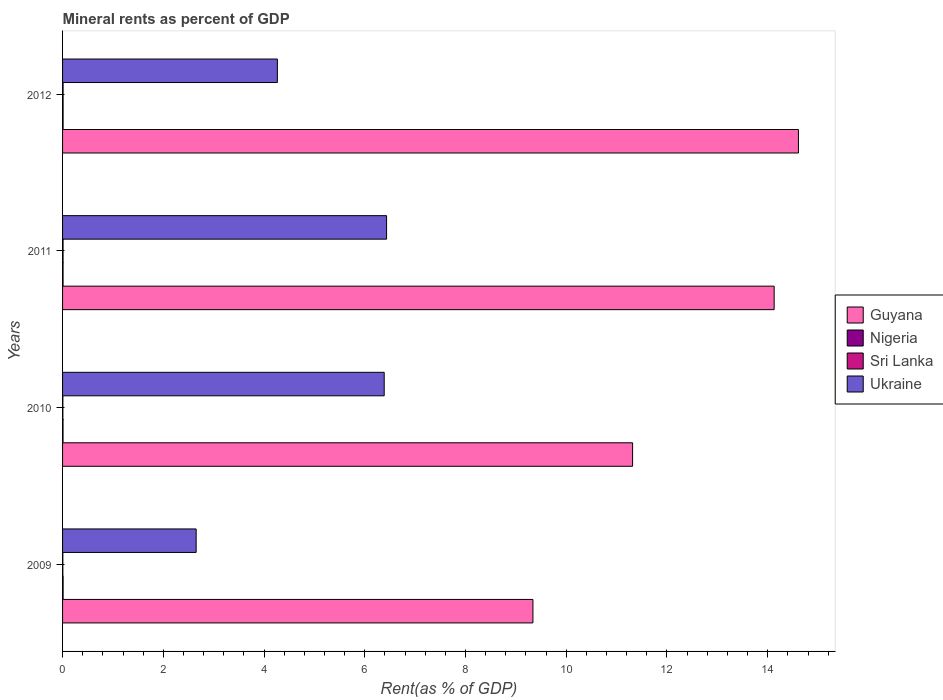How many groups of bars are there?
Give a very brief answer. 4. Are the number of bars per tick equal to the number of legend labels?
Your answer should be very brief. Yes. Are the number of bars on each tick of the Y-axis equal?
Your answer should be very brief. Yes. How many bars are there on the 3rd tick from the bottom?
Your answer should be very brief. 4. In how many cases, is the number of bars for a given year not equal to the number of legend labels?
Ensure brevity in your answer.  0. What is the mineral rent in Guyana in 2011?
Provide a short and direct response. 14.13. Across all years, what is the maximum mineral rent in Guyana?
Make the answer very short. 14.61. Across all years, what is the minimum mineral rent in Nigeria?
Offer a terse response. 0.01. In which year was the mineral rent in Guyana minimum?
Provide a succinct answer. 2009. What is the total mineral rent in Nigeria in the graph?
Offer a terse response. 0.04. What is the difference between the mineral rent in Nigeria in 2010 and that in 2012?
Offer a very short reply. -0. What is the difference between the mineral rent in Nigeria in 2011 and the mineral rent in Guyana in 2012?
Keep it short and to the point. -14.6. What is the average mineral rent in Guyana per year?
Provide a succinct answer. 12.35. In the year 2010, what is the difference between the mineral rent in Ukraine and mineral rent in Sri Lanka?
Your response must be concise. 6.38. What is the ratio of the mineral rent in Ukraine in 2011 to that in 2012?
Your answer should be compact. 1.51. Is the mineral rent in Guyana in 2009 less than that in 2010?
Offer a terse response. Yes. What is the difference between the highest and the second highest mineral rent in Sri Lanka?
Ensure brevity in your answer.  0. What is the difference between the highest and the lowest mineral rent in Nigeria?
Offer a terse response. 0. In how many years, is the mineral rent in Guyana greater than the average mineral rent in Guyana taken over all years?
Offer a terse response. 2. Is the sum of the mineral rent in Ukraine in 2009 and 2010 greater than the maximum mineral rent in Nigeria across all years?
Your response must be concise. Yes. Is it the case that in every year, the sum of the mineral rent in Sri Lanka and mineral rent in Guyana is greater than the sum of mineral rent in Nigeria and mineral rent in Ukraine?
Keep it short and to the point. Yes. What does the 4th bar from the top in 2011 represents?
Provide a short and direct response. Guyana. What does the 1st bar from the bottom in 2009 represents?
Give a very brief answer. Guyana. How many bars are there?
Keep it short and to the point. 16. How many years are there in the graph?
Keep it short and to the point. 4. What is the difference between two consecutive major ticks on the X-axis?
Your response must be concise. 2. Are the values on the major ticks of X-axis written in scientific E-notation?
Your answer should be compact. No. How many legend labels are there?
Keep it short and to the point. 4. What is the title of the graph?
Ensure brevity in your answer.  Mineral rents as percent of GDP. What is the label or title of the X-axis?
Offer a very short reply. Rent(as % of GDP). What is the label or title of the Y-axis?
Make the answer very short. Years. What is the Rent(as % of GDP) in Guyana in 2009?
Offer a very short reply. 9.34. What is the Rent(as % of GDP) in Nigeria in 2009?
Provide a succinct answer. 0.01. What is the Rent(as % of GDP) of Sri Lanka in 2009?
Your response must be concise. 0.01. What is the Rent(as % of GDP) in Ukraine in 2009?
Offer a very short reply. 2.65. What is the Rent(as % of GDP) of Guyana in 2010?
Offer a very short reply. 11.32. What is the Rent(as % of GDP) in Nigeria in 2010?
Provide a succinct answer. 0.01. What is the Rent(as % of GDP) of Sri Lanka in 2010?
Your answer should be very brief. 0.01. What is the Rent(as % of GDP) of Ukraine in 2010?
Offer a terse response. 6.39. What is the Rent(as % of GDP) in Guyana in 2011?
Offer a very short reply. 14.13. What is the Rent(as % of GDP) in Nigeria in 2011?
Your answer should be compact. 0.01. What is the Rent(as % of GDP) of Sri Lanka in 2011?
Give a very brief answer. 0.01. What is the Rent(as % of GDP) in Ukraine in 2011?
Your answer should be compact. 6.43. What is the Rent(as % of GDP) in Guyana in 2012?
Your response must be concise. 14.61. What is the Rent(as % of GDP) of Nigeria in 2012?
Ensure brevity in your answer.  0.01. What is the Rent(as % of GDP) in Sri Lanka in 2012?
Provide a succinct answer. 0.01. What is the Rent(as % of GDP) in Ukraine in 2012?
Your response must be concise. 4.26. Across all years, what is the maximum Rent(as % of GDP) in Guyana?
Make the answer very short. 14.61. Across all years, what is the maximum Rent(as % of GDP) in Nigeria?
Provide a short and direct response. 0.01. Across all years, what is the maximum Rent(as % of GDP) of Sri Lanka?
Make the answer very short. 0.01. Across all years, what is the maximum Rent(as % of GDP) in Ukraine?
Your response must be concise. 6.43. Across all years, what is the minimum Rent(as % of GDP) of Guyana?
Offer a very short reply. 9.34. Across all years, what is the minimum Rent(as % of GDP) of Nigeria?
Offer a very short reply. 0.01. Across all years, what is the minimum Rent(as % of GDP) in Sri Lanka?
Give a very brief answer. 0.01. Across all years, what is the minimum Rent(as % of GDP) in Ukraine?
Offer a very short reply. 2.65. What is the total Rent(as % of GDP) in Guyana in the graph?
Offer a terse response. 49.39. What is the total Rent(as % of GDP) of Nigeria in the graph?
Ensure brevity in your answer.  0.04. What is the total Rent(as % of GDP) of Sri Lanka in the graph?
Ensure brevity in your answer.  0.03. What is the total Rent(as % of GDP) of Ukraine in the graph?
Keep it short and to the point. 19.74. What is the difference between the Rent(as % of GDP) in Guyana in 2009 and that in 2010?
Keep it short and to the point. -1.98. What is the difference between the Rent(as % of GDP) in Nigeria in 2009 and that in 2010?
Your response must be concise. 0. What is the difference between the Rent(as % of GDP) in Sri Lanka in 2009 and that in 2010?
Ensure brevity in your answer.  -0. What is the difference between the Rent(as % of GDP) in Ukraine in 2009 and that in 2010?
Provide a short and direct response. -3.73. What is the difference between the Rent(as % of GDP) of Guyana in 2009 and that in 2011?
Your answer should be compact. -4.79. What is the difference between the Rent(as % of GDP) in Sri Lanka in 2009 and that in 2011?
Keep it short and to the point. -0. What is the difference between the Rent(as % of GDP) in Ukraine in 2009 and that in 2011?
Provide a succinct answer. -3.78. What is the difference between the Rent(as % of GDP) of Guyana in 2009 and that in 2012?
Give a very brief answer. -5.27. What is the difference between the Rent(as % of GDP) of Nigeria in 2009 and that in 2012?
Ensure brevity in your answer.  0. What is the difference between the Rent(as % of GDP) of Sri Lanka in 2009 and that in 2012?
Keep it short and to the point. -0. What is the difference between the Rent(as % of GDP) of Ukraine in 2009 and that in 2012?
Provide a short and direct response. -1.61. What is the difference between the Rent(as % of GDP) in Guyana in 2010 and that in 2011?
Ensure brevity in your answer.  -2.81. What is the difference between the Rent(as % of GDP) of Nigeria in 2010 and that in 2011?
Give a very brief answer. -0. What is the difference between the Rent(as % of GDP) of Sri Lanka in 2010 and that in 2011?
Your response must be concise. -0. What is the difference between the Rent(as % of GDP) of Ukraine in 2010 and that in 2011?
Your answer should be compact. -0.05. What is the difference between the Rent(as % of GDP) in Guyana in 2010 and that in 2012?
Make the answer very short. -3.29. What is the difference between the Rent(as % of GDP) in Nigeria in 2010 and that in 2012?
Your answer should be compact. -0. What is the difference between the Rent(as % of GDP) in Sri Lanka in 2010 and that in 2012?
Ensure brevity in your answer.  -0. What is the difference between the Rent(as % of GDP) of Ukraine in 2010 and that in 2012?
Offer a very short reply. 2.12. What is the difference between the Rent(as % of GDP) of Guyana in 2011 and that in 2012?
Your answer should be very brief. -0.48. What is the difference between the Rent(as % of GDP) in Nigeria in 2011 and that in 2012?
Keep it short and to the point. -0. What is the difference between the Rent(as % of GDP) of Sri Lanka in 2011 and that in 2012?
Offer a terse response. -0. What is the difference between the Rent(as % of GDP) of Ukraine in 2011 and that in 2012?
Keep it short and to the point. 2.17. What is the difference between the Rent(as % of GDP) of Guyana in 2009 and the Rent(as % of GDP) of Nigeria in 2010?
Ensure brevity in your answer.  9.33. What is the difference between the Rent(as % of GDP) of Guyana in 2009 and the Rent(as % of GDP) of Sri Lanka in 2010?
Offer a terse response. 9.33. What is the difference between the Rent(as % of GDP) in Guyana in 2009 and the Rent(as % of GDP) in Ukraine in 2010?
Offer a terse response. 2.95. What is the difference between the Rent(as % of GDP) in Nigeria in 2009 and the Rent(as % of GDP) in Sri Lanka in 2010?
Provide a short and direct response. 0. What is the difference between the Rent(as % of GDP) of Nigeria in 2009 and the Rent(as % of GDP) of Ukraine in 2010?
Your answer should be compact. -6.37. What is the difference between the Rent(as % of GDP) in Sri Lanka in 2009 and the Rent(as % of GDP) in Ukraine in 2010?
Keep it short and to the point. -6.38. What is the difference between the Rent(as % of GDP) in Guyana in 2009 and the Rent(as % of GDP) in Nigeria in 2011?
Your answer should be very brief. 9.33. What is the difference between the Rent(as % of GDP) in Guyana in 2009 and the Rent(as % of GDP) in Sri Lanka in 2011?
Your answer should be compact. 9.33. What is the difference between the Rent(as % of GDP) in Guyana in 2009 and the Rent(as % of GDP) in Ukraine in 2011?
Offer a terse response. 2.91. What is the difference between the Rent(as % of GDP) of Nigeria in 2009 and the Rent(as % of GDP) of Sri Lanka in 2011?
Make the answer very short. 0. What is the difference between the Rent(as % of GDP) of Nigeria in 2009 and the Rent(as % of GDP) of Ukraine in 2011?
Offer a very short reply. -6.42. What is the difference between the Rent(as % of GDP) of Sri Lanka in 2009 and the Rent(as % of GDP) of Ukraine in 2011?
Your response must be concise. -6.43. What is the difference between the Rent(as % of GDP) of Guyana in 2009 and the Rent(as % of GDP) of Nigeria in 2012?
Ensure brevity in your answer.  9.33. What is the difference between the Rent(as % of GDP) of Guyana in 2009 and the Rent(as % of GDP) of Sri Lanka in 2012?
Keep it short and to the point. 9.33. What is the difference between the Rent(as % of GDP) of Guyana in 2009 and the Rent(as % of GDP) of Ukraine in 2012?
Offer a very short reply. 5.07. What is the difference between the Rent(as % of GDP) of Nigeria in 2009 and the Rent(as % of GDP) of Ukraine in 2012?
Your answer should be compact. -4.25. What is the difference between the Rent(as % of GDP) of Sri Lanka in 2009 and the Rent(as % of GDP) of Ukraine in 2012?
Provide a succinct answer. -4.26. What is the difference between the Rent(as % of GDP) of Guyana in 2010 and the Rent(as % of GDP) of Nigeria in 2011?
Provide a succinct answer. 11.31. What is the difference between the Rent(as % of GDP) in Guyana in 2010 and the Rent(as % of GDP) in Sri Lanka in 2011?
Ensure brevity in your answer.  11.31. What is the difference between the Rent(as % of GDP) in Guyana in 2010 and the Rent(as % of GDP) in Ukraine in 2011?
Provide a short and direct response. 4.88. What is the difference between the Rent(as % of GDP) in Nigeria in 2010 and the Rent(as % of GDP) in Sri Lanka in 2011?
Provide a succinct answer. -0. What is the difference between the Rent(as % of GDP) in Nigeria in 2010 and the Rent(as % of GDP) in Ukraine in 2011?
Your response must be concise. -6.42. What is the difference between the Rent(as % of GDP) in Sri Lanka in 2010 and the Rent(as % of GDP) in Ukraine in 2011?
Your response must be concise. -6.43. What is the difference between the Rent(as % of GDP) in Guyana in 2010 and the Rent(as % of GDP) in Nigeria in 2012?
Give a very brief answer. 11.31. What is the difference between the Rent(as % of GDP) of Guyana in 2010 and the Rent(as % of GDP) of Sri Lanka in 2012?
Give a very brief answer. 11.31. What is the difference between the Rent(as % of GDP) in Guyana in 2010 and the Rent(as % of GDP) in Ukraine in 2012?
Make the answer very short. 7.05. What is the difference between the Rent(as % of GDP) of Nigeria in 2010 and the Rent(as % of GDP) of Sri Lanka in 2012?
Make the answer very short. -0. What is the difference between the Rent(as % of GDP) of Nigeria in 2010 and the Rent(as % of GDP) of Ukraine in 2012?
Provide a short and direct response. -4.26. What is the difference between the Rent(as % of GDP) in Sri Lanka in 2010 and the Rent(as % of GDP) in Ukraine in 2012?
Your answer should be compact. -4.26. What is the difference between the Rent(as % of GDP) of Guyana in 2011 and the Rent(as % of GDP) of Nigeria in 2012?
Offer a very short reply. 14.12. What is the difference between the Rent(as % of GDP) in Guyana in 2011 and the Rent(as % of GDP) in Sri Lanka in 2012?
Give a very brief answer. 14.12. What is the difference between the Rent(as % of GDP) of Guyana in 2011 and the Rent(as % of GDP) of Ukraine in 2012?
Make the answer very short. 9.86. What is the difference between the Rent(as % of GDP) of Nigeria in 2011 and the Rent(as % of GDP) of Sri Lanka in 2012?
Make the answer very short. -0. What is the difference between the Rent(as % of GDP) in Nigeria in 2011 and the Rent(as % of GDP) in Ukraine in 2012?
Keep it short and to the point. -4.25. What is the difference between the Rent(as % of GDP) in Sri Lanka in 2011 and the Rent(as % of GDP) in Ukraine in 2012?
Make the answer very short. -4.25. What is the average Rent(as % of GDP) of Guyana per year?
Your answer should be compact. 12.35. What is the average Rent(as % of GDP) of Nigeria per year?
Your answer should be very brief. 0.01. What is the average Rent(as % of GDP) in Sri Lanka per year?
Provide a succinct answer. 0.01. What is the average Rent(as % of GDP) in Ukraine per year?
Offer a terse response. 4.93. In the year 2009, what is the difference between the Rent(as % of GDP) of Guyana and Rent(as % of GDP) of Nigeria?
Offer a very short reply. 9.33. In the year 2009, what is the difference between the Rent(as % of GDP) in Guyana and Rent(as % of GDP) in Sri Lanka?
Provide a succinct answer. 9.33. In the year 2009, what is the difference between the Rent(as % of GDP) of Guyana and Rent(as % of GDP) of Ukraine?
Give a very brief answer. 6.69. In the year 2009, what is the difference between the Rent(as % of GDP) of Nigeria and Rent(as % of GDP) of Sri Lanka?
Your answer should be compact. 0.01. In the year 2009, what is the difference between the Rent(as % of GDP) of Nigeria and Rent(as % of GDP) of Ukraine?
Give a very brief answer. -2.64. In the year 2009, what is the difference between the Rent(as % of GDP) in Sri Lanka and Rent(as % of GDP) in Ukraine?
Offer a very short reply. -2.65. In the year 2010, what is the difference between the Rent(as % of GDP) in Guyana and Rent(as % of GDP) in Nigeria?
Give a very brief answer. 11.31. In the year 2010, what is the difference between the Rent(as % of GDP) in Guyana and Rent(as % of GDP) in Sri Lanka?
Offer a very short reply. 11.31. In the year 2010, what is the difference between the Rent(as % of GDP) in Guyana and Rent(as % of GDP) in Ukraine?
Offer a very short reply. 4.93. In the year 2010, what is the difference between the Rent(as % of GDP) of Nigeria and Rent(as % of GDP) of Sri Lanka?
Your response must be concise. 0. In the year 2010, what is the difference between the Rent(as % of GDP) of Nigeria and Rent(as % of GDP) of Ukraine?
Provide a short and direct response. -6.38. In the year 2010, what is the difference between the Rent(as % of GDP) in Sri Lanka and Rent(as % of GDP) in Ukraine?
Your answer should be compact. -6.38. In the year 2011, what is the difference between the Rent(as % of GDP) of Guyana and Rent(as % of GDP) of Nigeria?
Provide a short and direct response. 14.12. In the year 2011, what is the difference between the Rent(as % of GDP) in Guyana and Rent(as % of GDP) in Sri Lanka?
Give a very brief answer. 14.12. In the year 2011, what is the difference between the Rent(as % of GDP) in Guyana and Rent(as % of GDP) in Ukraine?
Provide a short and direct response. 7.7. In the year 2011, what is the difference between the Rent(as % of GDP) in Nigeria and Rent(as % of GDP) in Ukraine?
Keep it short and to the point. -6.42. In the year 2011, what is the difference between the Rent(as % of GDP) of Sri Lanka and Rent(as % of GDP) of Ukraine?
Give a very brief answer. -6.42. In the year 2012, what is the difference between the Rent(as % of GDP) of Guyana and Rent(as % of GDP) of Nigeria?
Make the answer very short. 14.6. In the year 2012, what is the difference between the Rent(as % of GDP) of Guyana and Rent(as % of GDP) of Sri Lanka?
Your response must be concise. 14.6. In the year 2012, what is the difference between the Rent(as % of GDP) in Guyana and Rent(as % of GDP) in Ukraine?
Offer a very short reply. 10.34. In the year 2012, what is the difference between the Rent(as % of GDP) of Nigeria and Rent(as % of GDP) of Sri Lanka?
Your answer should be compact. -0. In the year 2012, what is the difference between the Rent(as % of GDP) of Nigeria and Rent(as % of GDP) of Ukraine?
Ensure brevity in your answer.  -4.25. In the year 2012, what is the difference between the Rent(as % of GDP) in Sri Lanka and Rent(as % of GDP) in Ukraine?
Keep it short and to the point. -4.25. What is the ratio of the Rent(as % of GDP) of Guyana in 2009 to that in 2010?
Offer a terse response. 0.83. What is the ratio of the Rent(as % of GDP) in Nigeria in 2009 to that in 2010?
Provide a succinct answer. 1.17. What is the ratio of the Rent(as % of GDP) in Sri Lanka in 2009 to that in 2010?
Your answer should be very brief. 0.91. What is the ratio of the Rent(as % of GDP) of Ukraine in 2009 to that in 2010?
Provide a short and direct response. 0.42. What is the ratio of the Rent(as % of GDP) of Guyana in 2009 to that in 2011?
Offer a very short reply. 0.66. What is the ratio of the Rent(as % of GDP) in Nigeria in 2009 to that in 2011?
Offer a very short reply. 1.1. What is the ratio of the Rent(as % of GDP) in Sri Lanka in 2009 to that in 2011?
Your answer should be very brief. 0.57. What is the ratio of the Rent(as % of GDP) of Ukraine in 2009 to that in 2011?
Give a very brief answer. 0.41. What is the ratio of the Rent(as % of GDP) of Guyana in 2009 to that in 2012?
Offer a very short reply. 0.64. What is the ratio of the Rent(as % of GDP) in Nigeria in 2009 to that in 2012?
Give a very brief answer. 1.04. What is the ratio of the Rent(as % of GDP) of Sri Lanka in 2009 to that in 2012?
Your answer should be very brief. 0.53. What is the ratio of the Rent(as % of GDP) in Ukraine in 2009 to that in 2012?
Give a very brief answer. 0.62. What is the ratio of the Rent(as % of GDP) in Guyana in 2010 to that in 2011?
Ensure brevity in your answer.  0.8. What is the ratio of the Rent(as % of GDP) in Nigeria in 2010 to that in 2011?
Ensure brevity in your answer.  0.94. What is the ratio of the Rent(as % of GDP) of Sri Lanka in 2010 to that in 2011?
Give a very brief answer. 0.63. What is the ratio of the Rent(as % of GDP) in Ukraine in 2010 to that in 2011?
Your answer should be very brief. 0.99. What is the ratio of the Rent(as % of GDP) in Guyana in 2010 to that in 2012?
Your response must be concise. 0.77. What is the ratio of the Rent(as % of GDP) of Nigeria in 2010 to that in 2012?
Your response must be concise. 0.89. What is the ratio of the Rent(as % of GDP) in Sri Lanka in 2010 to that in 2012?
Offer a terse response. 0.59. What is the ratio of the Rent(as % of GDP) in Ukraine in 2010 to that in 2012?
Your answer should be very brief. 1.5. What is the ratio of the Rent(as % of GDP) in Guyana in 2011 to that in 2012?
Provide a short and direct response. 0.97. What is the ratio of the Rent(as % of GDP) in Nigeria in 2011 to that in 2012?
Offer a very short reply. 0.94. What is the ratio of the Rent(as % of GDP) of Sri Lanka in 2011 to that in 2012?
Keep it short and to the point. 0.93. What is the ratio of the Rent(as % of GDP) of Ukraine in 2011 to that in 2012?
Give a very brief answer. 1.51. What is the difference between the highest and the second highest Rent(as % of GDP) of Guyana?
Provide a short and direct response. 0.48. What is the difference between the highest and the second highest Rent(as % of GDP) of Nigeria?
Provide a succinct answer. 0. What is the difference between the highest and the second highest Rent(as % of GDP) in Sri Lanka?
Your answer should be very brief. 0. What is the difference between the highest and the second highest Rent(as % of GDP) of Ukraine?
Provide a succinct answer. 0.05. What is the difference between the highest and the lowest Rent(as % of GDP) of Guyana?
Your answer should be compact. 5.27. What is the difference between the highest and the lowest Rent(as % of GDP) of Nigeria?
Ensure brevity in your answer.  0. What is the difference between the highest and the lowest Rent(as % of GDP) in Sri Lanka?
Your answer should be compact. 0. What is the difference between the highest and the lowest Rent(as % of GDP) of Ukraine?
Make the answer very short. 3.78. 